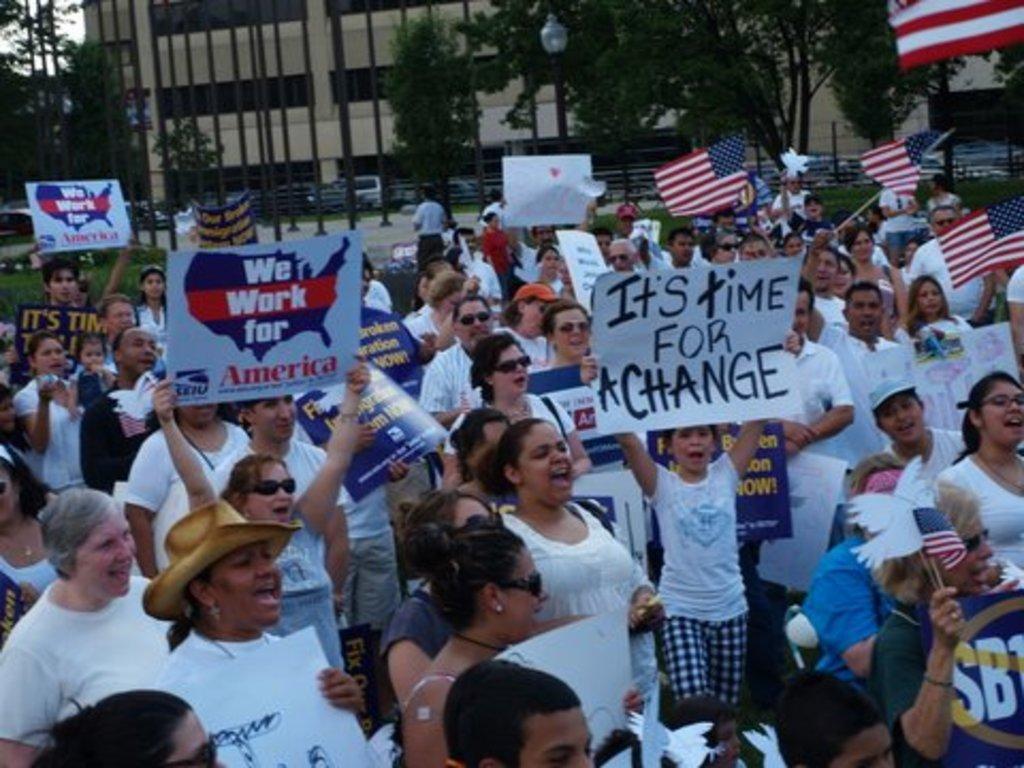Describe this image in one or two sentences. In the picture we can see some group of persons standing, some are holding boards and flags in their hands and in the background of the picture there are some trees, buildings. 